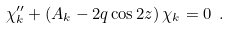<formula> <loc_0><loc_0><loc_500><loc_500>\chi _ { k } ^ { \prime \prime } + \left ( A _ { k } - 2 q \cos 2 z \right ) \chi _ { k } = 0 \ .</formula> 